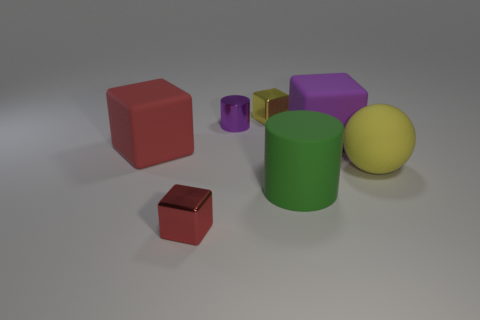Subtract 1 blocks. How many blocks are left? 3 Add 1 red shiny things. How many objects exist? 8 Subtract all cubes. How many objects are left? 3 Add 6 large yellow matte objects. How many large yellow matte objects are left? 7 Add 6 cylinders. How many cylinders exist? 8 Subtract 1 red blocks. How many objects are left? 6 Subtract all large yellow matte balls. Subtract all green cylinders. How many objects are left? 5 